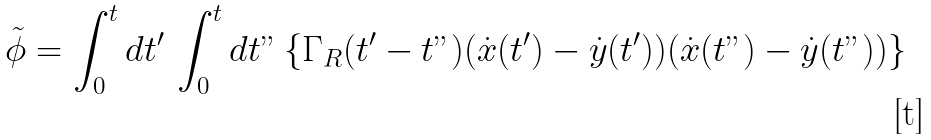<formula> <loc_0><loc_0><loc_500><loc_500>\tilde { \phi } = \int ^ { t } _ { 0 } { d t ^ { \prime } } \, \int ^ { t } _ { 0 } { d t " } \left \{ \Gamma _ { R } ( t ^ { \prime } - t " ) ( \dot { x } ( t ^ { \prime } ) - \dot { y } ( t ^ { \prime } ) ) ( \dot { x } ( t " ) - \dot { y } ( t " ) ) \right \}</formula> 